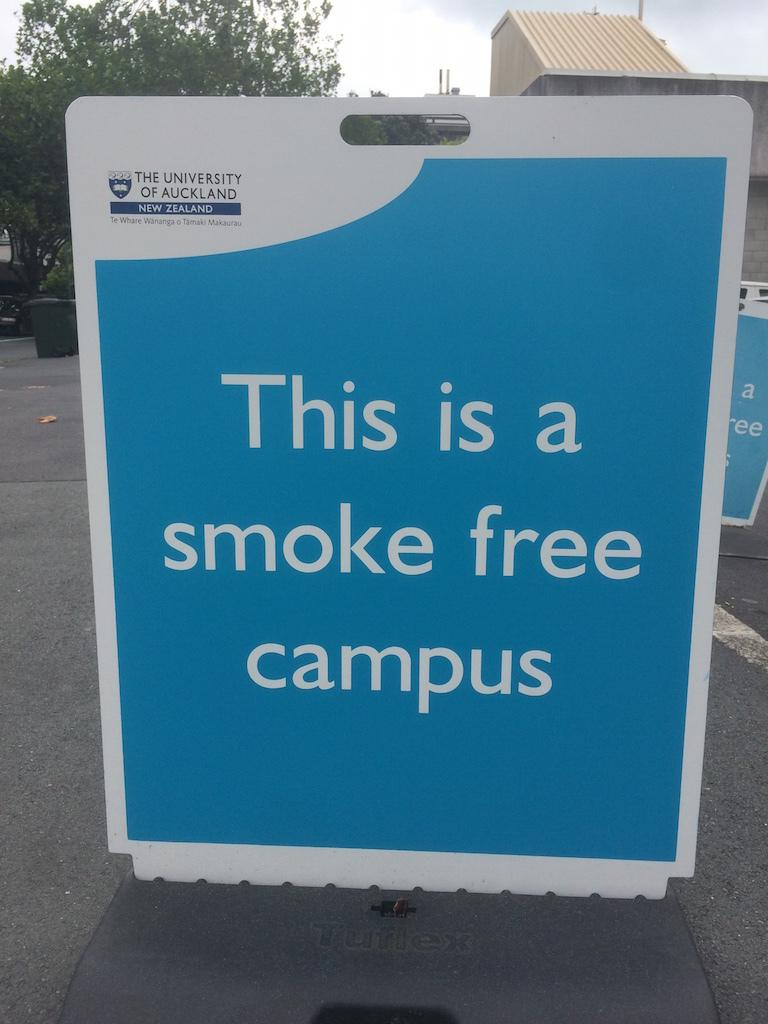<image>
Give a short and clear explanation of the subsequent image. A sign in blue and white reading 'this is a smoke free campus' 